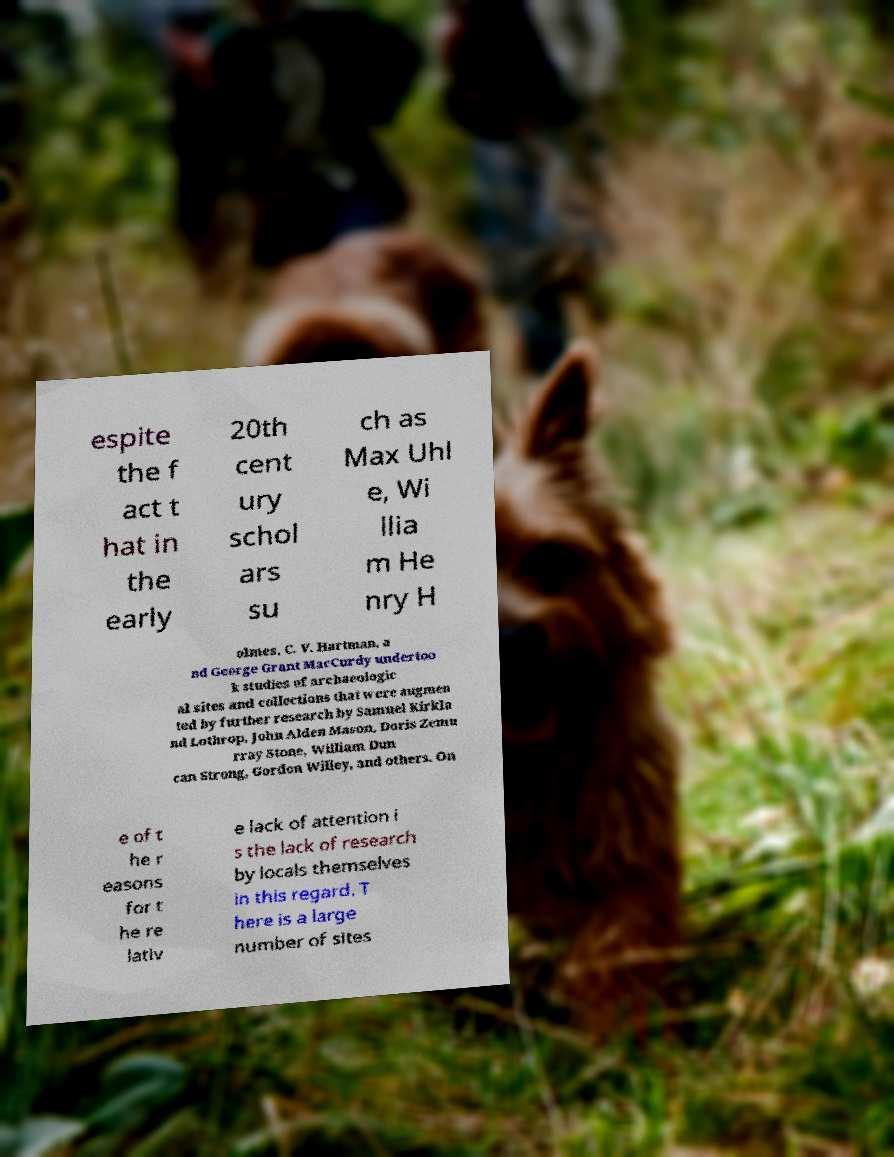Please read and relay the text visible in this image. What does it say? espite the f act t hat in the early 20th cent ury schol ars su ch as Max Uhl e, Wi llia m He nry H olmes, C. V. Hartman, a nd George Grant MacCurdy undertoo k studies of archaeologic al sites and collections that were augmen ted by further research by Samuel Kirkla nd Lothrop, John Alden Mason, Doris Zemu rray Stone, William Dun can Strong, Gordon Willey, and others. On e of t he r easons for t he re lativ e lack of attention i s the lack of research by locals themselves in this regard. T here is a large number of sites 